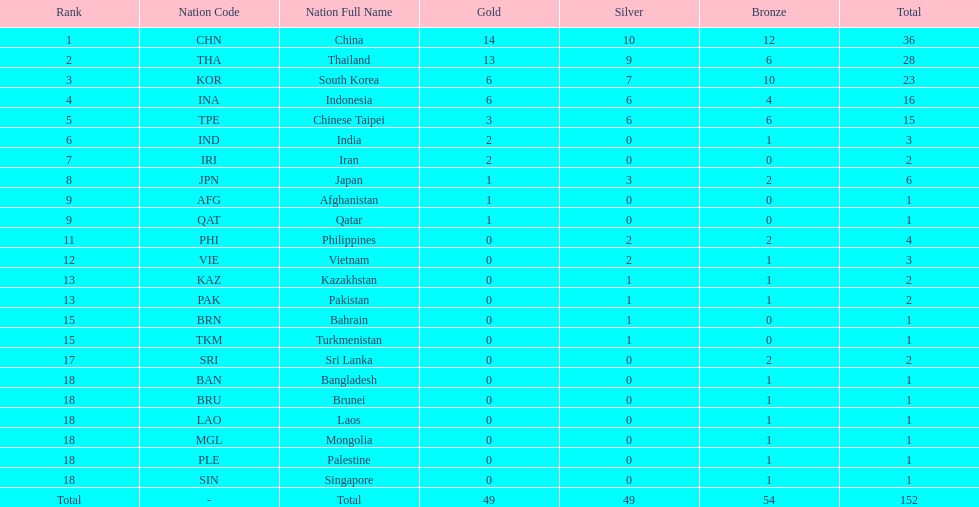Which countries won the same number of gold medals as japan? Afghanistan (AFG), Qatar (QAT). 